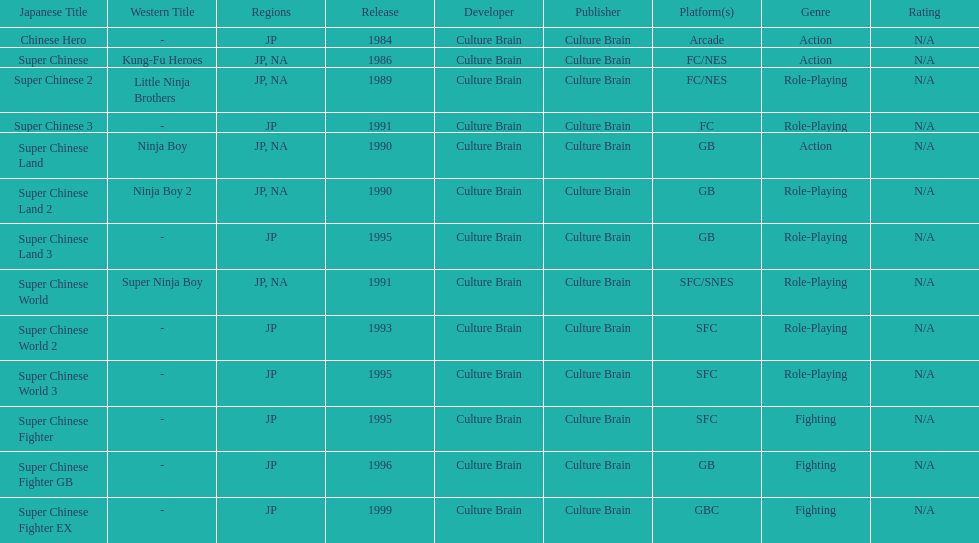When was the last super chinese game released? 1999. 